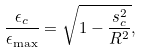<formula> <loc_0><loc_0><loc_500><loc_500>\frac { \epsilon _ { c } } { \epsilon _ { \max } } = \sqrt { 1 - \frac { s _ { c } ^ { 2 } } { R ^ { 2 } } } ,</formula> 